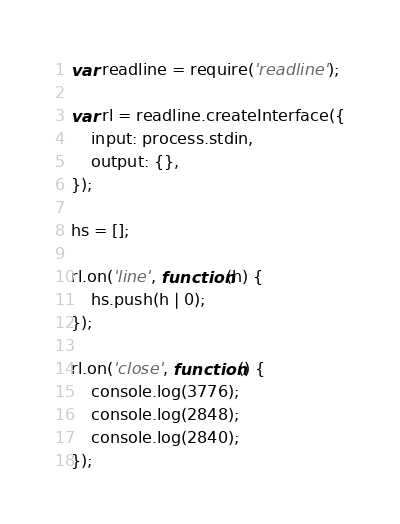<code> <loc_0><loc_0><loc_500><loc_500><_JavaScript_>var readline = require('readline');
 
var rl = readline.createInterface({
    input: process.stdin,
    output: {},
});
 
hs = [];
 
rl.on('line', function(h) {
    hs.push(h | 0);
});
 
rl.on('close', function() {
    console.log(3776);
    console.log(2848);
    console.log(2840);
});</code> 